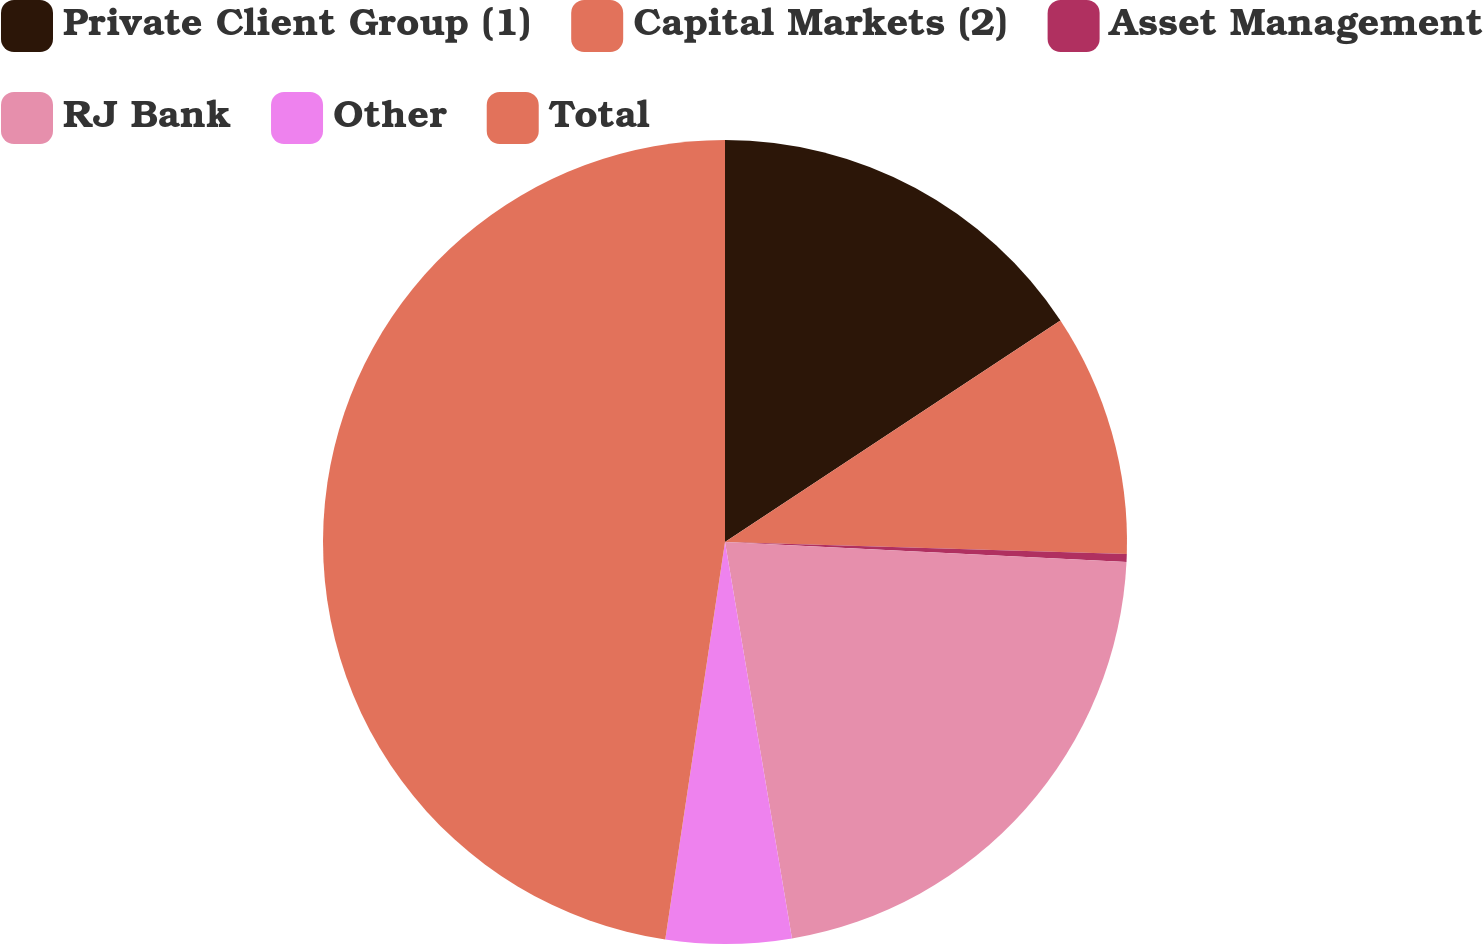Convert chart. <chart><loc_0><loc_0><loc_500><loc_500><pie_chart><fcel>Private Client Group (1)<fcel>Capital Markets (2)<fcel>Asset Management<fcel>RJ Bank<fcel>Other<fcel>Total<nl><fcel>15.71%<fcel>9.77%<fcel>0.31%<fcel>21.55%<fcel>5.04%<fcel>47.63%<nl></chart> 